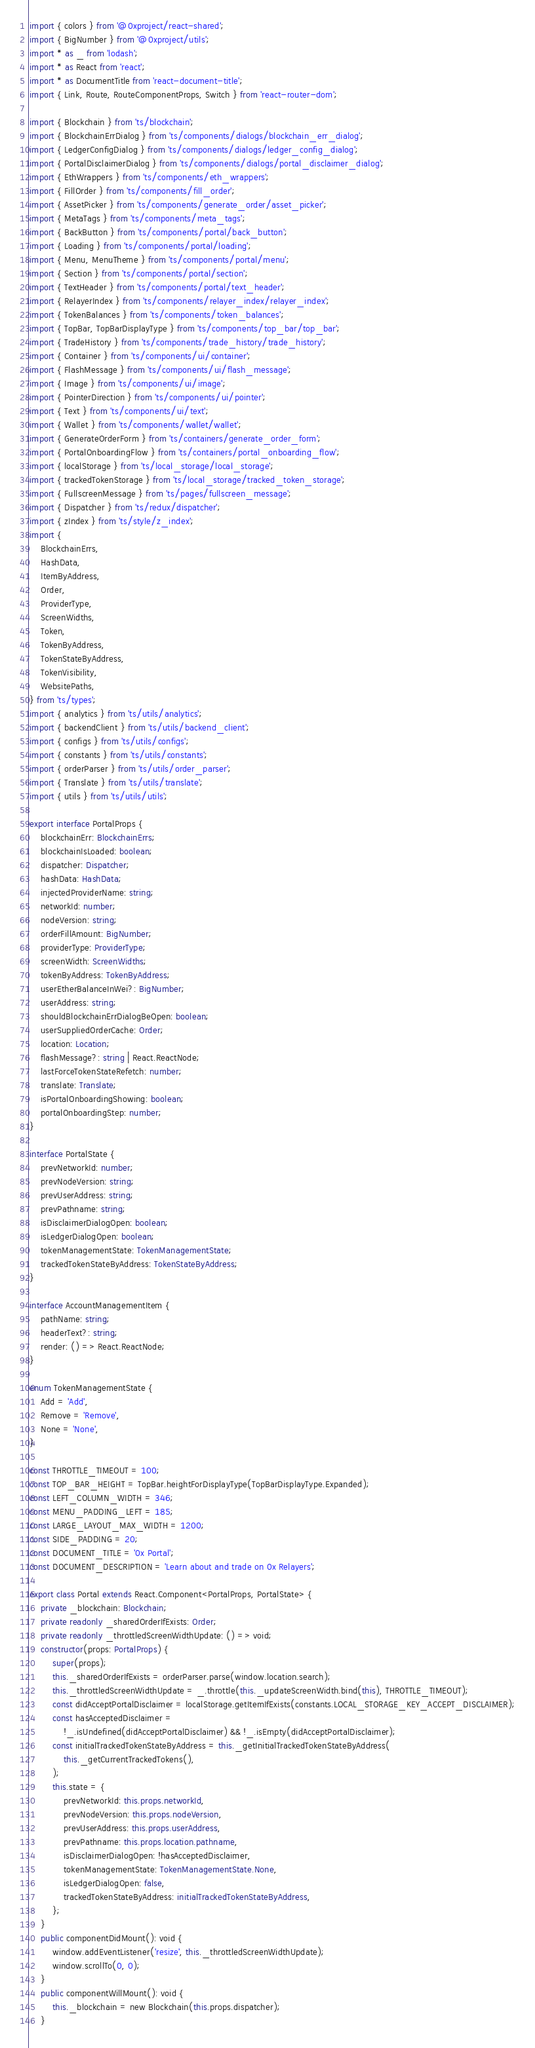Convert code to text. <code><loc_0><loc_0><loc_500><loc_500><_TypeScript_>import { colors } from '@0xproject/react-shared';
import { BigNumber } from '@0xproject/utils';
import * as _ from 'lodash';
import * as React from 'react';
import * as DocumentTitle from 'react-document-title';
import { Link, Route, RouteComponentProps, Switch } from 'react-router-dom';

import { Blockchain } from 'ts/blockchain';
import { BlockchainErrDialog } from 'ts/components/dialogs/blockchain_err_dialog';
import { LedgerConfigDialog } from 'ts/components/dialogs/ledger_config_dialog';
import { PortalDisclaimerDialog } from 'ts/components/dialogs/portal_disclaimer_dialog';
import { EthWrappers } from 'ts/components/eth_wrappers';
import { FillOrder } from 'ts/components/fill_order';
import { AssetPicker } from 'ts/components/generate_order/asset_picker';
import { MetaTags } from 'ts/components/meta_tags';
import { BackButton } from 'ts/components/portal/back_button';
import { Loading } from 'ts/components/portal/loading';
import { Menu, MenuTheme } from 'ts/components/portal/menu';
import { Section } from 'ts/components/portal/section';
import { TextHeader } from 'ts/components/portal/text_header';
import { RelayerIndex } from 'ts/components/relayer_index/relayer_index';
import { TokenBalances } from 'ts/components/token_balances';
import { TopBar, TopBarDisplayType } from 'ts/components/top_bar/top_bar';
import { TradeHistory } from 'ts/components/trade_history/trade_history';
import { Container } from 'ts/components/ui/container';
import { FlashMessage } from 'ts/components/ui/flash_message';
import { Image } from 'ts/components/ui/image';
import { PointerDirection } from 'ts/components/ui/pointer';
import { Text } from 'ts/components/ui/text';
import { Wallet } from 'ts/components/wallet/wallet';
import { GenerateOrderForm } from 'ts/containers/generate_order_form';
import { PortalOnboardingFlow } from 'ts/containers/portal_onboarding_flow';
import { localStorage } from 'ts/local_storage/local_storage';
import { trackedTokenStorage } from 'ts/local_storage/tracked_token_storage';
import { FullscreenMessage } from 'ts/pages/fullscreen_message';
import { Dispatcher } from 'ts/redux/dispatcher';
import { zIndex } from 'ts/style/z_index';
import {
    BlockchainErrs,
    HashData,
    ItemByAddress,
    Order,
    ProviderType,
    ScreenWidths,
    Token,
    TokenByAddress,
    TokenStateByAddress,
    TokenVisibility,
    WebsitePaths,
} from 'ts/types';
import { analytics } from 'ts/utils/analytics';
import { backendClient } from 'ts/utils/backend_client';
import { configs } from 'ts/utils/configs';
import { constants } from 'ts/utils/constants';
import { orderParser } from 'ts/utils/order_parser';
import { Translate } from 'ts/utils/translate';
import { utils } from 'ts/utils/utils';

export interface PortalProps {
    blockchainErr: BlockchainErrs;
    blockchainIsLoaded: boolean;
    dispatcher: Dispatcher;
    hashData: HashData;
    injectedProviderName: string;
    networkId: number;
    nodeVersion: string;
    orderFillAmount: BigNumber;
    providerType: ProviderType;
    screenWidth: ScreenWidths;
    tokenByAddress: TokenByAddress;
    userEtherBalanceInWei?: BigNumber;
    userAddress: string;
    shouldBlockchainErrDialogBeOpen: boolean;
    userSuppliedOrderCache: Order;
    location: Location;
    flashMessage?: string | React.ReactNode;
    lastForceTokenStateRefetch: number;
    translate: Translate;
    isPortalOnboardingShowing: boolean;
    portalOnboardingStep: number;
}

interface PortalState {
    prevNetworkId: number;
    prevNodeVersion: string;
    prevUserAddress: string;
    prevPathname: string;
    isDisclaimerDialogOpen: boolean;
    isLedgerDialogOpen: boolean;
    tokenManagementState: TokenManagementState;
    trackedTokenStateByAddress: TokenStateByAddress;
}

interface AccountManagementItem {
    pathName: string;
    headerText?: string;
    render: () => React.ReactNode;
}

enum TokenManagementState {
    Add = 'Add',
    Remove = 'Remove',
    None = 'None',
}

const THROTTLE_TIMEOUT = 100;
const TOP_BAR_HEIGHT = TopBar.heightForDisplayType(TopBarDisplayType.Expanded);
const LEFT_COLUMN_WIDTH = 346;
const MENU_PADDING_LEFT = 185;
const LARGE_LAYOUT_MAX_WIDTH = 1200;
const SIDE_PADDING = 20;
const DOCUMENT_TITLE = '0x Portal';
const DOCUMENT_DESCRIPTION = 'Learn about and trade on 0x Relayers';

export class Portal extends React.Component<PortalProps, PortalState> {
    private _blockchain: Blockchain;
    private readonly _sharedOrderIfExists: Order;
    private readonly _throttledScreenWidthUpdate: () => void;
    constructor(props: PortalProps) {
        super(props);
        this._sharedOrderIfExists = orderParser.parse(window.location.search);
        this._throttledScreenWidthUpdate = _.throttle(this._updateScreenWidth.bind(this), THROTTLE_TIMEOUT);
        const didAcceptPortalDisclaimer = localStorage.getItemIfExists(constants.LOCAL_STORAGE_KEY_ACCEPT_DISCLAIMER);
        const hasAcceptedDisclaimer =
            !_.isUndefined(didAcceptPortalDisclaimer) && !_.isEmpty(didAcceptPortalDisclaimer);
        const initialTrackedTokenStateByAddress = this._getInitialTrackedTokenStateByAddress(
            this._getCurrentTrackedTokens(),
        );
        this.state = {
            prevNetworkId: this.props.networkId,
            prevNodeVersion: this.props.nodeVersion,
            prevUserAddress: this.props.userAddress,
            prevPathname: this.props.location.pathname,
            isDisclaimerDialogOpen: !hasAcceptedDisclaimer,
            tokenManagementState: TokenManagementState.None,
            isLedgerDialogOpen: false,
            trackedTokenStateByAddress: initialTrackedTokenStateByAddress,
        };
    }
    public componentDidMount(): void {
        window.addEventListener('resize', this._throttledScreenWidthUpdate);
        window.scrollTo(0, 0);
    }
    public componentWillMount(): void {
        this._blockchain = new Blockchain(this.props.dispatcher);
    }</code> 